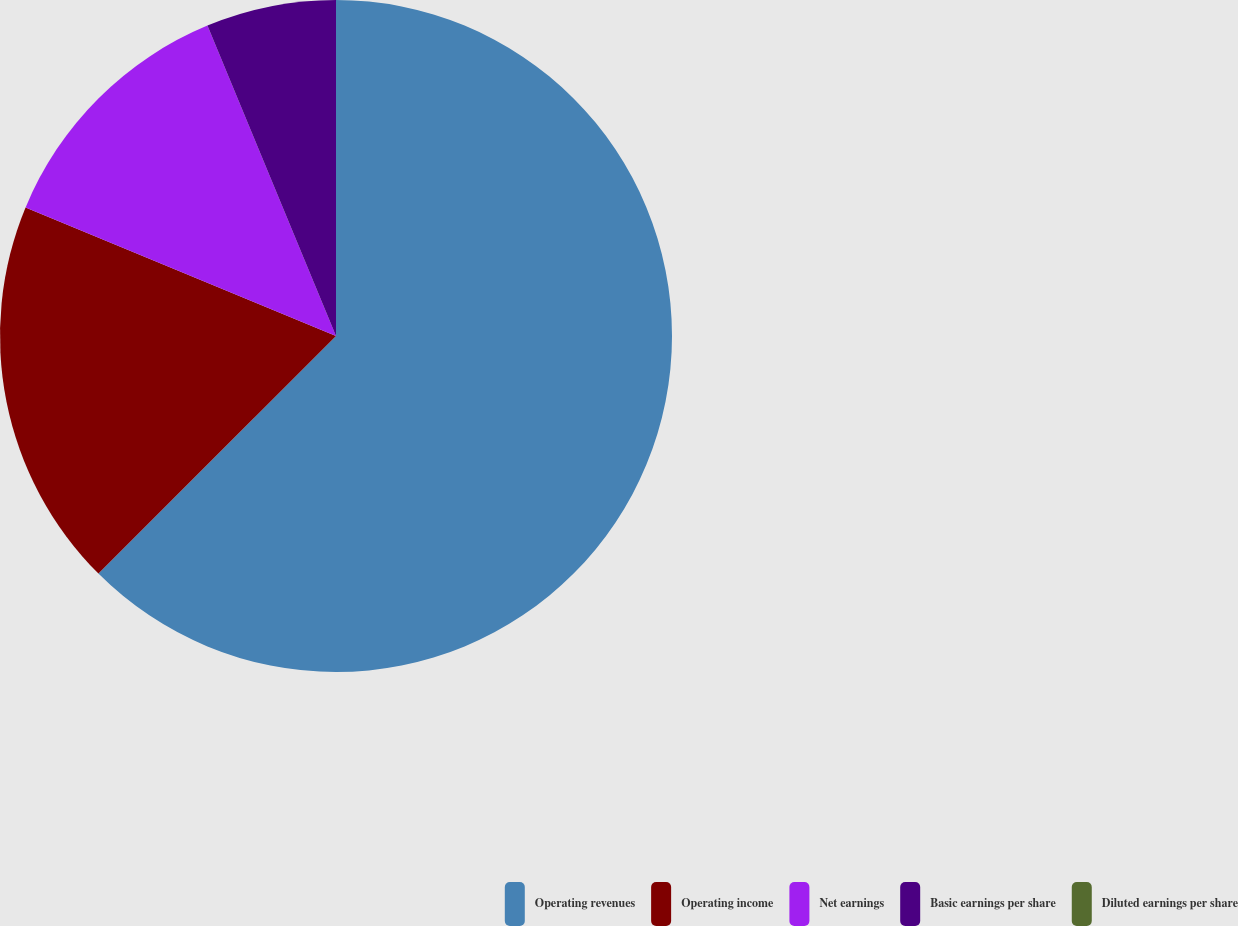Convert chart. <chart><loc_0><loc_0><loc_500><loc_500><pie_chart><fcel>Operating revenues<fcel>Operating income<fcel>Net earnings<fcel>Basic earnings per share<fcel>Diluted earnings per share<nl><fcel>62.5%<fcel>18.75%<fcel>12.5%<fcel>6.25%<fcel>0.0%<nl></chart> 